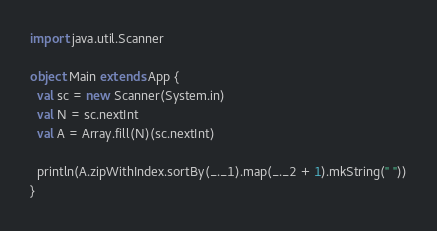<code> <loc_0><loc_0><loc_500><loc_500><_Scala_>import java.util.Scanner

object Main extends App {
  val sc = new Scanner(System.in)
  val N = sc.nextInt
  val A = Array.fill(N)(sc.nextInt)

  println(A.zipWithIndex.sortBy(_._1).map(_._2 + 1).mkString(" "))
}
</code> 